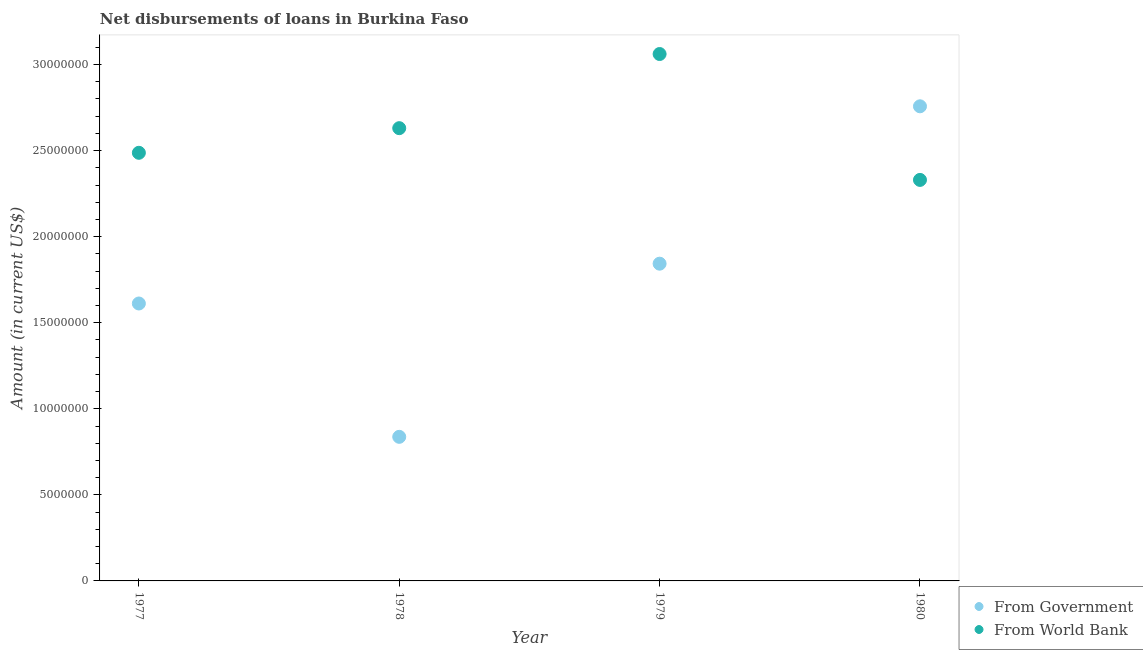How many different coloured dotlines are there?
Your response must be concise. 2. Is the number of dotlines equal to the number of legend labels?
Provide a succinct answer. Yes. What is the net disbursements of loan from government in 1980?
Offer a very short reply. 2.76e+07. Across all years, what is the maximum net disbursements of loan from government?
Keep it short and to the point. 2.76e+07. Across all years, what is the minimum net disbursements of loan from world bank?
Your response must be concise. 2.33e+07. In which year was the net disbursements of loan from world bank maximum?
Make the answer very short. 1979. In which year was the net disbursements of loan from government minimum?
Ensure brevity in your answer.  1978. What is the total net disbursements of loan from government in the graph?
Offer a terse response. 7.05e+07. What is the difference between the net disbursements of loan from government in 1977 and that in 1980?
Your response must be concise. -1.15e+07. What is the difference between the net disbursements of loan from government in 1978 and the net disbursements of loan from world bank in 1977?
Provide a short and direct response. -1.65e+07. What is the average net disbursements of loan from government per year?
Ensure brevity in your answer.  1.76e+07. In the year 1979, what is the difference between the net disbursements of loan from government and net disbursements of loan from world bank?
Provide a short and direct response. -1.22e+07. What is the ratio of the net disbursements of loan from government in 1978 to that in 1980?
Make the answer very short. 0.3. Is the net disbursements of loan from government in 1977 less than that in 1980?
Offer a terse response. Yes. What is the difference between the highest and the second highest net disbursements of loan from world bank?
Your answer should be very brief. 4.31e+06. What is the difference between the highest and the lowest net disbursements of loan from world bank?
Provide a succinct answer. 7.31e+06. Is the sum of the net disbursements of loan from government in 1978 and 1979 greater than the maximum net disbursements of loan from world bank across all years?
Provide a succinct answer. No. How many dotlines are there?
Offer a very short reply. 2. What is the difference between two consecutive major ticks on the Y-axis?
Keep it short and to the point. 5.00e+06. Does the graph contain any zero values?
Make the answer very short. No. Does the graph contain grids?
Make the answer very short. No. What is the title of the graph?
Make the answer very short. Net disbursements of loans in Burkina Faso. Does "Constant 2005 US$" appear as one of the legend labels in the graph?
Make the answer very short. No. What is the label or title of the Y-axis?
Your answer should be compact. Amount (in current US$). What is the Amount (in current US$) of From Government in 1977?
Your response must be concise. 1.61e+07. What is the Amount (in current US$) of From World Bank in 1977?
Provide a succinct answer. 2.49e+07. What is the Amount (in current US$) of From Government in 1978?
Provide a succinct answer. 8.37e+06. What is the Amount (in current US$) in From World Bank in 1978?
Your response must be concise. 2.63e+07. What is the Amount (in current US$) in From Government in 1979?
Ensure brevity in your answer.  1.84e+07. What is the Amount (in current US$) in From World Bank in 1979?
Give a very brief answer. 3.06e+07. What is the Amount (in current US$) of From Government in 1980?
Ensure brevity in your answer.  2.76e+07. What is the Amount (in current US$) of From World Bank in 1980?
Your answer should be compact. 2.33e+07. Across all years, what is the maximum Amount (in current US$) in From Government?
Offer a very short reply. 2.76e+07. Across all years, what is the maximum Amount (in current US$) in From World Bank?
Give a very brief answer. 3.06e+07. Across all years, what is the minimum Amount (in current US$) of From Government?
Ensure brevity in your answer.  8.37e+06. Across all years, what is the minimum Amount (in current US$) in From World Bank?
Keep it short and to the point. 2.33e+07. What is the total Amount (in current US$) of From Government in the graph?
Provide a succinct answer. 7.05e+07. What is the total Amount (in current US$) of From World Bank in the graph?
Provide a succinct answer. 1.05e+08. What is the difference between the Amount (in current US$) in From Government in 1977 and that in 1978?
Your answer should be very brief. 7.75e+06. What is the difference between the Amount (in current US$) of From World Bank in 1977 and that in 1978?
Give a very brief answer. -1.43e+06. What is the difference between the Amount (in current US$) in From Government in 1977 and that in 1979?
Offer a terse response. -2.31e+06. What is the difference between the Amount (in current US$) of From World Bank in 1977 and that in 1979?
Offer a terse response. -5.74e+06. What is the difference between the Amount (in current US$) in From Government in 1977 and that in 1980?
Keep it short and to the point. -1.15e+07. What is the difference between the Amount (in current US$) in From World Bank in 1977 and that in 1980?
Give a very brief answer. 1.58e+06. What is the difference between the Amount (in current US$) in From Government in 1978 and that in 1979?
Provide a short and direct response. -1.01e+07. What is the difference between the Amount (in current US$) of From World Bank in 1978 and that in 1979?
Your answer should be very brief. -4.31e+06. What is the difference between the Amount (in current US$) of From Government in 1978 and that in 1980?
Make the answer very short. -1.92e+07. What is the difference between the Amount (in current US$) in From World Bank in 1978 and that in 1980?
Ensure brevity in your answer.  3.01e+06. What is the difference between the Amount (in current US$) of From Government in 1979 and that in 1980?
Offer a terse response. -9.14e+06. What is the difference between the Amount (in current US$) of From World Bank in 1979 and that in 1980?
Make the answer very short. 7.31e+06. What is the difference between the Amount (in current US$) in From Government in 1977 and the Amount (in current US$) in From World Bank in 1978?
Ensure brevity in your answer.  -1.02e+07. What is the difference between the Amount (in current US$) of From Government in 1977 and the Amount (in current US$) of From World Bank in 1979?
Provide a short and direct response. -1.45e+07. What is the difference between the Amount (in current US$) in From Government in 1977 and the Amount (in current US$) in From World Bank in 1980?
Your answer should be very brief. -7.18e+06. What is the difference between the Amount (in current US$) of From Government in 1978 and the Amount (in current US$) of From World Bank in 1979?
Keep it short and to the point. -2.22e+07. What is the difference between the Amount (in current US$) of From Government in 1978 and the Amount (in current US$) of From World Bank in 1980?
Your answer should be compact. -1.49e+07. What is the difference between the Amount (in current US$) in From Government in 1979 and the Amount (in current US$) in From World Bank in 1980?
Offer a very short reply. -4.87e+06. What is the average Amount (in current US$) in From Government per year?
Your answer should be compact. 1.76e+07. What is the average Amount (in current US$) of From World Bank per year?
Ensure brevity in your answer.  2.63e+07. In the year 1977, what is the difference between the Amount (in current US$) of From Government and Amount (in current US$) of From World Bank?
Your answer should be very brief. -8.76e+06. In the year 1978, what is the difference between the Amount (in current US$) of From Government and Amount (in current US$) of From World Bank?
Provide a succinct answer. -1.79e+07. In the year 1979, what is the difference between the Amount (in current US$) of From Government and Amount (in current US$) of From World Bank?
Your answer should be compact. -1.22e+07. In the year 1980, what is the difference between the Amount (in current US$) in From Government and Amount (in current US$) in From World Bank?
Your answer should be compact. 4.28e+06. What is the ratio of the Amount (in current US$) of From Government in 1977 to that in 1978?
Your response must be concise. 1.93. What is the ratio of the Amount (in current US$) in From World Bank in 1977 to that in 1978?
Offer a very short reply. 0.95. What is the ratio of the Amount (in current US$) in From Government in 1977 to that in 1979?
Offer a very short reply. 0.87. What is the ratio of the Amount (in current US$) of From World Bank in 1977 to that in 1979?
Your response must be concise. 0.81. What is the ratio of the Amount (in current US$) of From Government in 1977 to that in 1980?
Make the answer very short. 0.58. What is the ratio of the Amount (in current US$) in From World Bank in 1977 to that in 1980?
Offer a terse response. 1.07. What is the ratio of the Amount (in current US$) in From Government in 1978 to that in 1979?
Your response must be concise. 0.45. What is the ratio of the Amount (in current US$) in From World Bank in 1978 to that in 1979?
Offer a terse response. 0.86. What is the ratio of the Amount (in current US$) in From Government in 1978 to that in 1980?
Provide a succinct answer. 0.3. What is the ratio of the Amount (in current US$) of From World Bank in 1978 to that in 1980?
Make the answer very short. 1.13. What is the ratio of the Amount (in current US$) in From Government in 1979 to that in 1980?
Ensure brevity in your answer.  0.67. What is the ratio of the Amount (in current US$) of From World Bank in 1979 to that in 1980?
Provide a succinct answer. 1.31. What is the difference between the highest and the second highest Amount (in current US$) in From Government?
Your response must be concise. 9.14e+06. What is the difference between the highest and the second highest Amount (in current US$) of From World Bank?
Make the answer very short. 4.31e+06. What is the difference between the highest and the lowest Amount (in current US$) of From Government?
Ensure brevity in your answer.  1.92e+07. What is the difference between the highest and the lowest Amount (in current US$) of From World Bank?
Your answer should be very brief. 7.31e+06. 